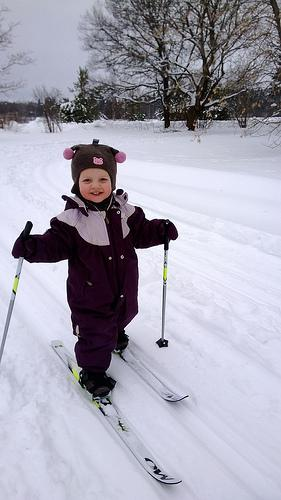State the number of eyes, noses, and mouths visible in the image, and whether they belong to the young girl. There are 2 eyes, 1 nose, and 1 mouth visible in the image, all of which belong to the young girl. What is the predominant color of the young girl's outfit? The predominant color of the young girl's outfit is purple. What type of environment are the people in the image in, and how can you tell? The image shows a snow-covered environment, evidenced by ski equipment, snow on trees, and a snowy ground. Identify the feeling expressed by the child's face in the image. The young girl's face expresses happiness as she smiles while skiing. Describe the hat the child is wearing and its specific details. The child is wearing a brown and pink knitted hat with pink pom poms and a frog image on it. Do the ski tracks in the image look well-groomed or powder-filled? Explain your answer. The ski tracks appear well-groomed, as there are visible lines and organization in the snow. Estimate the number of trees visible in the image. There are around 4-5 trees visible in the image, covered in snow. How many ski poles is the child holding, and what are their colors? The child is holding two white ski poles with yellow stripes. Explain the overall atmosphere of the image based on its subjects and surroundings. The image portrays a cheerful and wintry atmosphere, with a young girl skiing in a snowy landscape surrounded by snow-covered trees. In terms of image quality, how clear are the objects in the image? Provide a brief evaluation. The objects in the image are relatively clear, with distinguishable details such as colors, patterns, and facial expressions. Is the young girl wearing a green ski suit? The instruction is misleading because the girl is wearing a purple ski suit, not a green one. Dramatically describe the image. In a vast winter wonderland, a triumphant young girl conquers snowy slopes with her powerful skis, leaving her indelible mark on the pristine landscape as she gracefully glides beneath towering snow-clad pines. In the image, what event is taking place? a child snow skiing Evaluate the girl's emotional state based on her face. happy What color are the ski poles? white and grey Can you spot any brand wording on the tip of the ski? yes Is the girl's hat brown and pink or green and yellow? brown and pink Are the ski poles blue with red stripes? No, it's not mentioned in the image. What is the most noticeable color on the girl's jacket? pink Explain the layout of the trees in the background. tall deciduous trees behind the skier, an evergreen tree behind the skier How many ski poles does the child have? two Are the ski tracks in the snow purple? This instruction is misleading because the ski tracks are described to be in white snow, not purple. The color of the ski tracks themselves is not mentioned, but it's likely they match the snow color. Is there any sign of weather in the image? snowing and overcast Describe the scene depicted in the image in a poetic manner. Amidst snow-laden trees, a wistful sky, and powdery trails, a joyful child adorned in a purple winter embrace skis gracefully, her spirit seemingly in tune with nature's wintry symphony. Create a short fictional story inspired by the image. Once upon a frosty winter morning, a young girl embarked on a magical ski adventure through a snow-covered forest. Along the way, she befriended woodland creatures who marveled at her vibrant attire and infectious smile as she skillfully maneuvered the serene, snowy trails. Describe the young girl's hat in detail. brown and pink knit ski cap with pink pom poms and a pink frog image Identify the activity that the young girl is engaged in. snow skiing What is the prominent color of the sky in the image? grey What color is the young girl's ski equipment? purple Does the girl have a green stocking cap with yellow pom poms? The instruction is misleading because the girl's stocking cap is brown and pink with pink pom poms, not green with yellow pom poms. What type of trees are covered in snow? pine and deciduous trees What type of trail is the girl skiing on? well groomed ski trail 